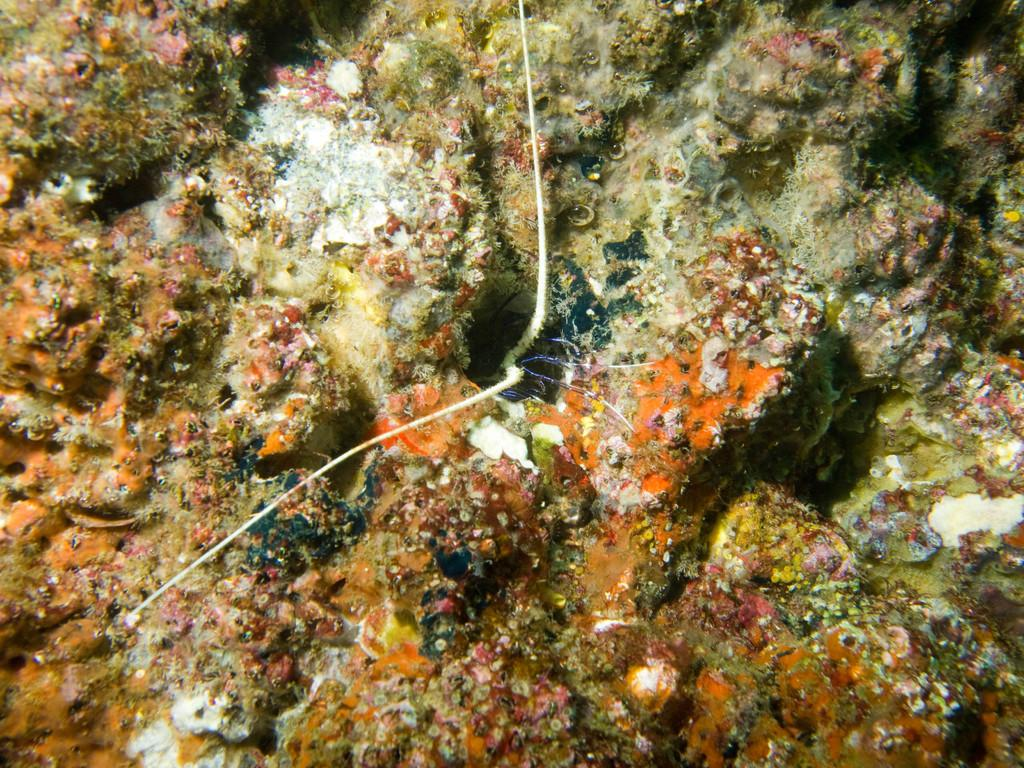What type of plants are visible in the image? There are submarine plants in the image. Where might this image have been taken? The image may have been taken in the ocean. What type of plot is being developed in the image? There is no plot being developed in the image, as it is a photograph of submarine plants in their natural environment. 